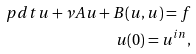Convert formula to latex. <formula><loc_0><loc_0><loc_500><loc_500>\ p d t { u } + \nu A u + B ( u , u ) = f \\ u ( 0 ) = u ^ { i n } ,</formula> 